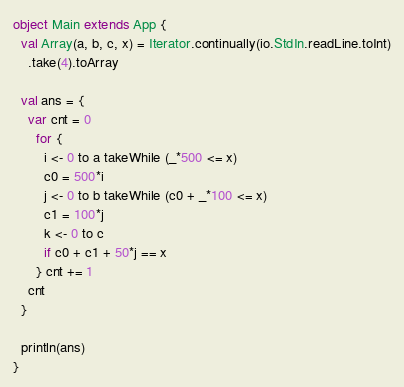Convert code to text. <code><loc_0><loc_0><loc_500><loc_500><_Scala_>object Main extends App {
  val Array(a, b, c, x) = Iterator.continually(io.StdIn.readLine.toInt)
    .take(4).toArray

  val ans = {
    var cnt = 0
      for {
        i <- 0 to a takeWhile (_*500 <= x)
        c0 = 500*i
        j <- 0 to b takeWhile (c0 + _*100 <= x)
        c1 = 100*j
        k <- 0 to c
        if c0 + c1 + 50*j == x
      } cnt += 1
    cnt
  }

  println(ans)
}</code> 